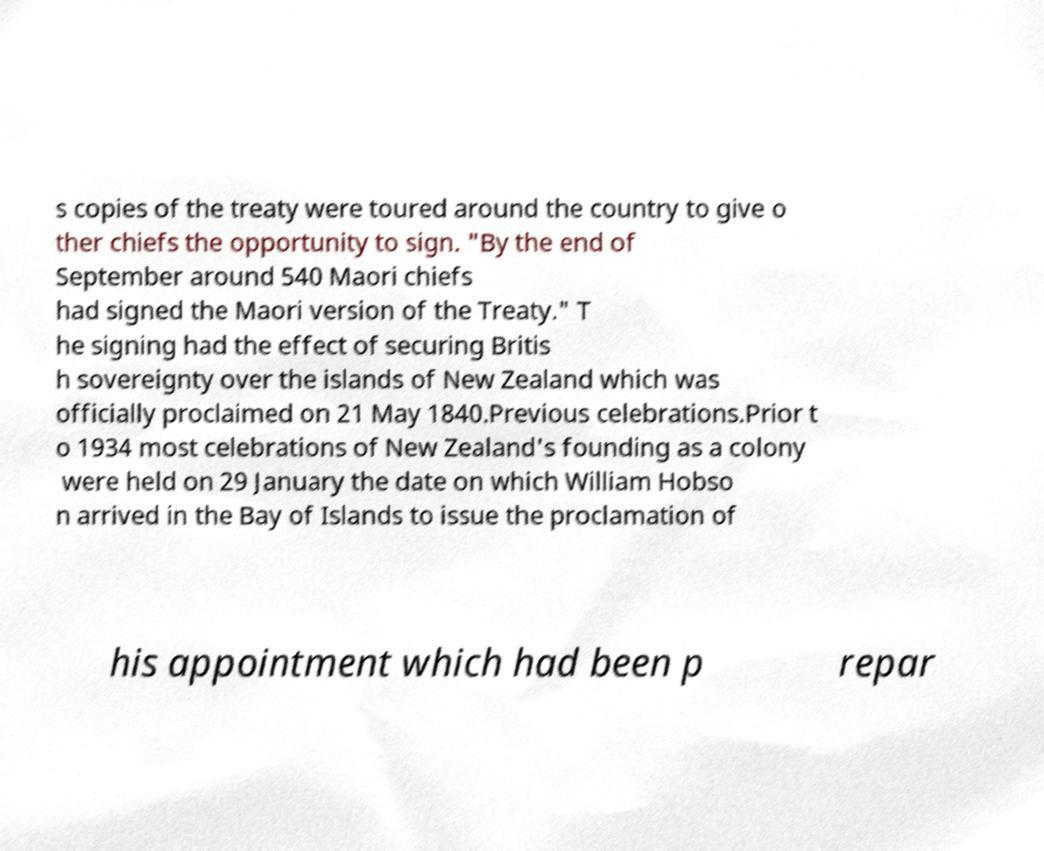Please identify and transcribe the text found in this image. s copies of the treaty were toured around the country to give o ther chiefs the opportunity to sign. "By the end of September around 540 Maori chiefs had signed the Maori version of the Treaty." T he signing had the effect of securing Britis h sovereignty over the islands of New Zealand which was officially proclaimed on 21 May 1840.Previous celebrations.Prior t o 1934 most celebrations of New Zealand's founding as a colony were held on 29 January the date on which William Hobso n arrived in the Bay of Islands to issue the proclamation of his appointment which had been p repar 